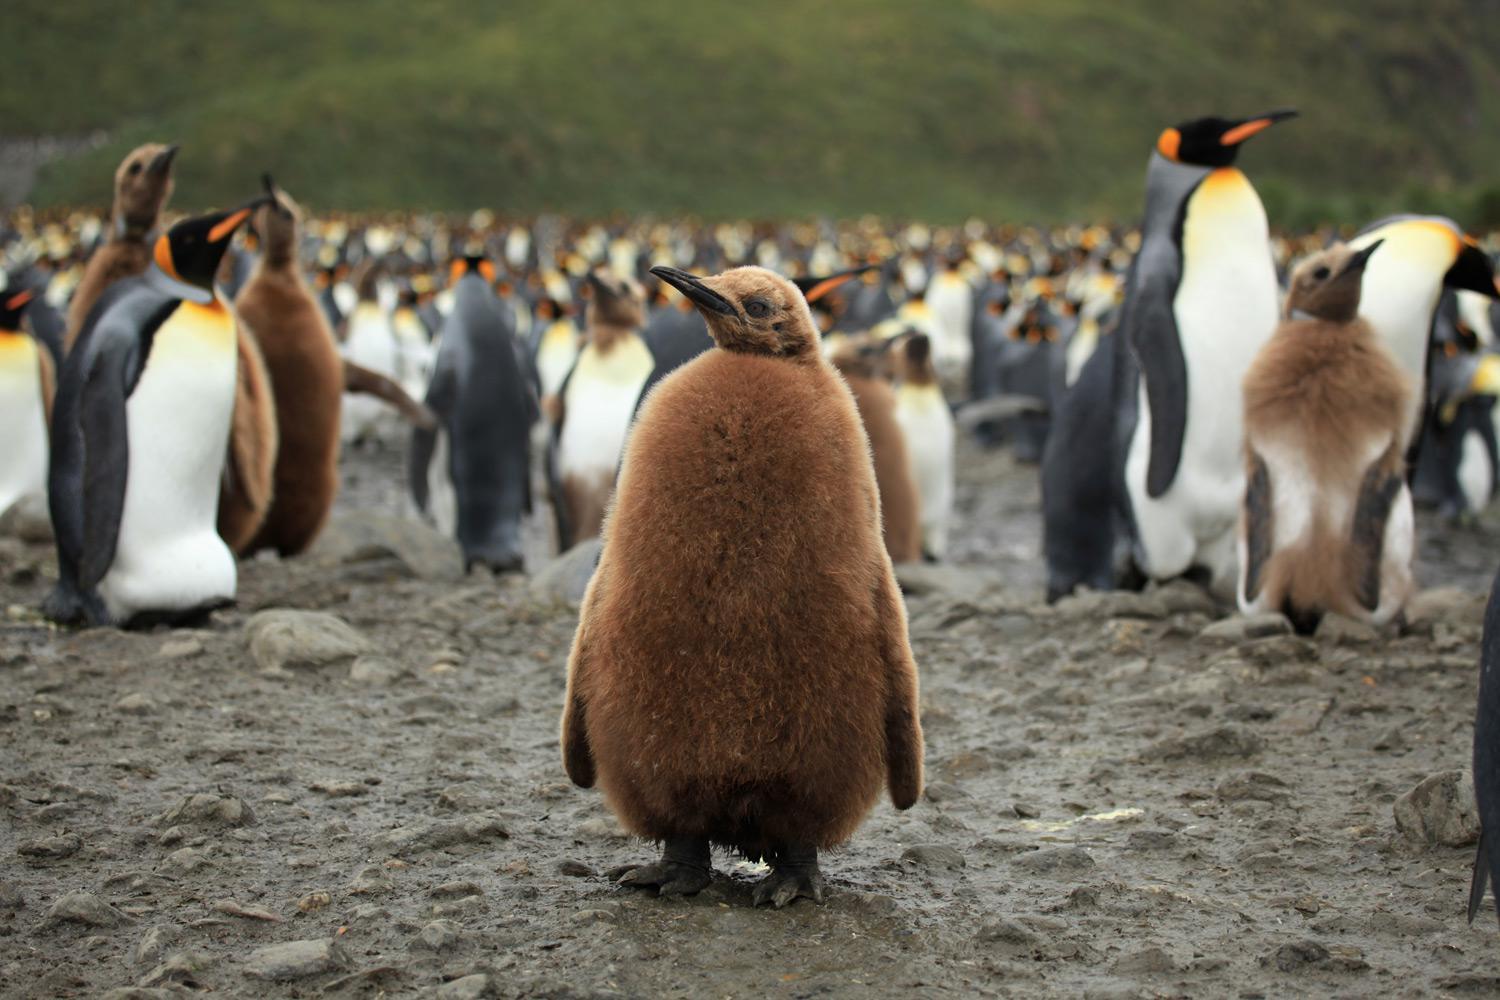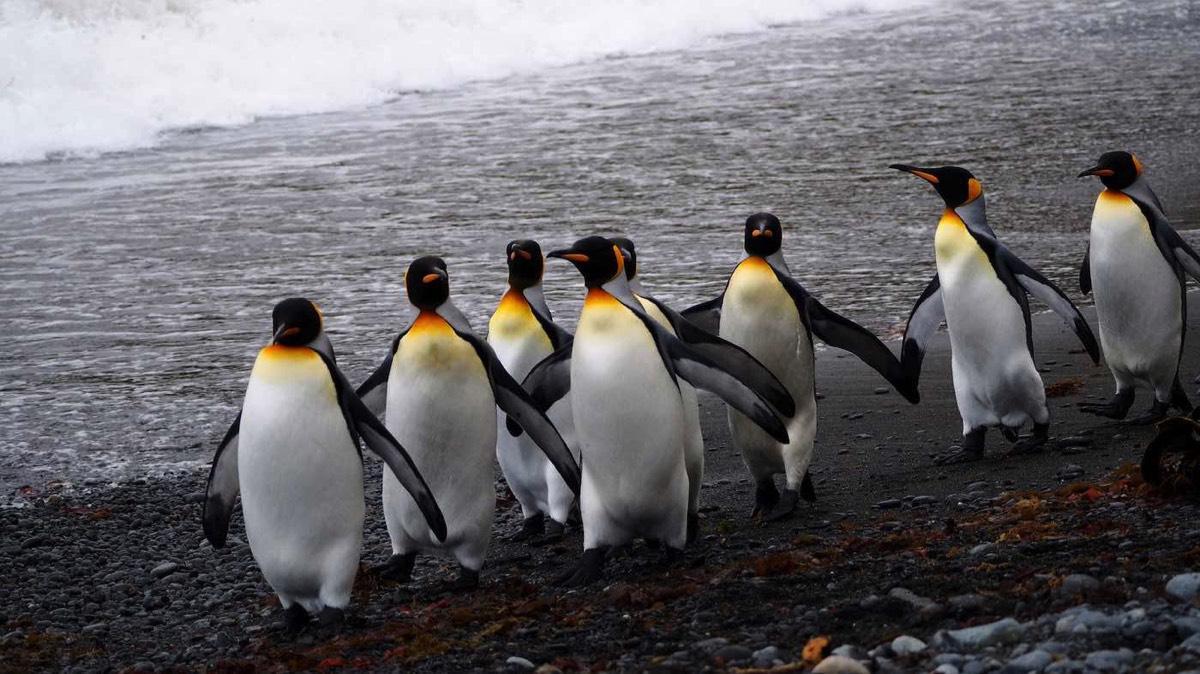The first image is the image on the left, the second image is the image on the right. For the images shown, is this caption "There are no more than three penguins standing on the ground." true? Answer yes or no. No. The first image is the image on the left, the second image is the image on the right. Considering the images on both sides, is "At least one image contains at least five penguins." valid? Answer yes or no. Yes. 